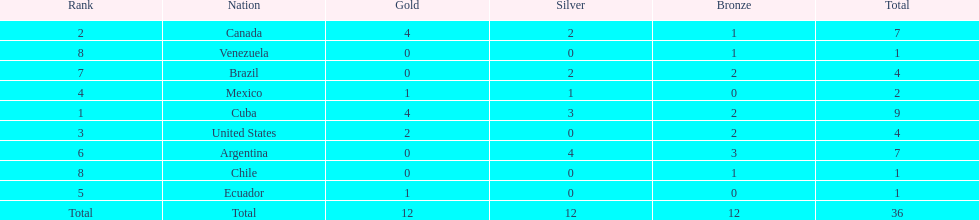Who is ranked #1? Cuba. 